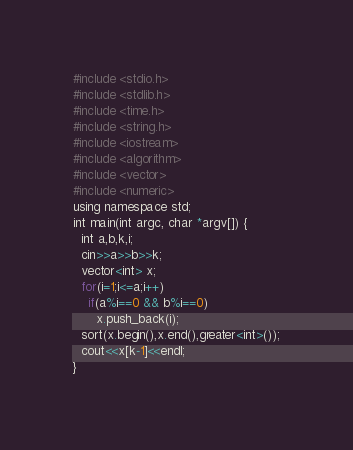<code> <loc_0><loc_0><loc_500><loc_500><_Python_>#include <stdio.h>
#include <stdlib.h>
#include <time.h>
#include <string.h>
#include <iostream>
#include <algorithm>
#include <vector>
#include <numeric>
using namespace std;
int main(int argc, char *argv[]) {
  int a,b,k,i;
  cin>>a>>b>>k;
  vector<int> x;
  for(i=1;i<=a;i++)
    if(a%i==0 && b%i==0)
      x.push_back(i);
  sort(x.begin(),x.end(),greater<int>());
  cout<<x[k-1]<<endl;
}
</code> 